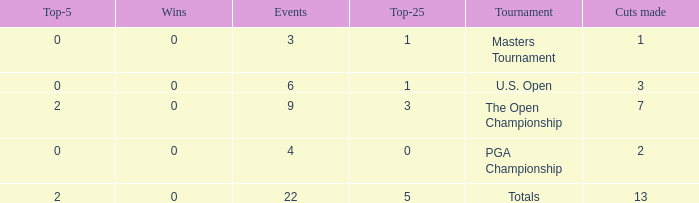What is the total number of wins for events with under 2 top-5s, under 5 top-25s, and more than 4 events played? 1.0. 